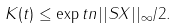Convert formula to latex. <formula><loc_0><loc_0><loc_500><loc_500>K ( t ) \leq \exp { t n | | S X | | _ { \infty } / 2 } .</formula> 